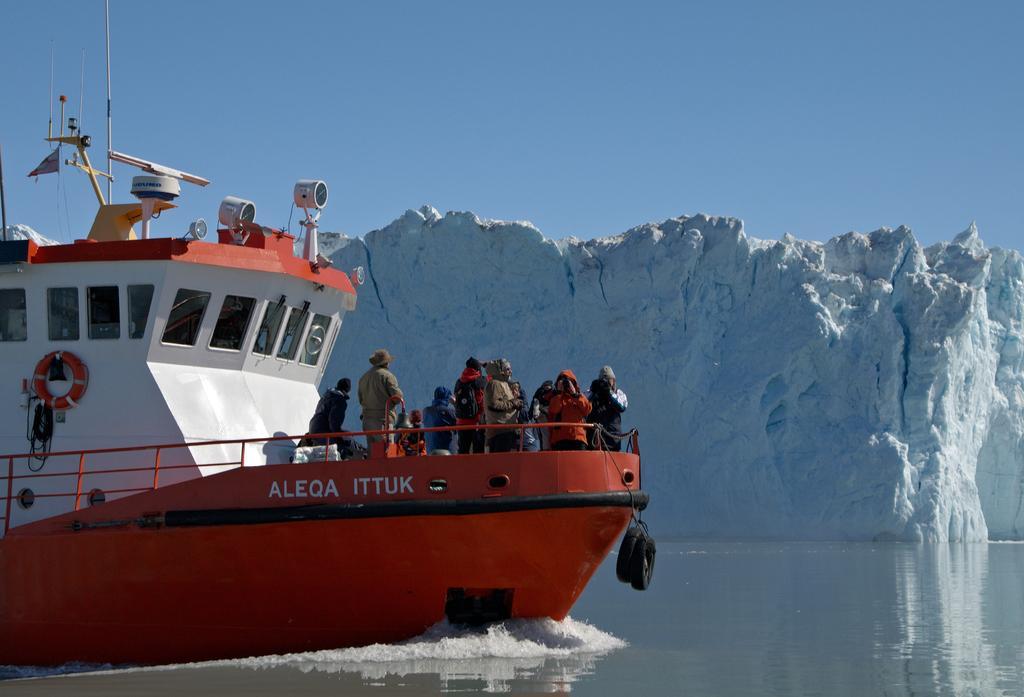Can you describe this image briefly? In this image at the bottom there is a river, in the river there is one boat and in the boat there are some people are standing and also there are some objects in the boat. In the background there is a mountain, on the top of the image there is sky. 